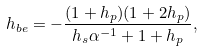Convert formula to latex. <formula><loc_0><loc_0><loc_500><loc_500>h _ { b e } = - \frac { ( 1 + h _ { p } ) ( 1 + 2 h _ { p } ) } { h _ { s } \alpha ^ { - 1 } + 1 + h _ { p } } ,</formula> 